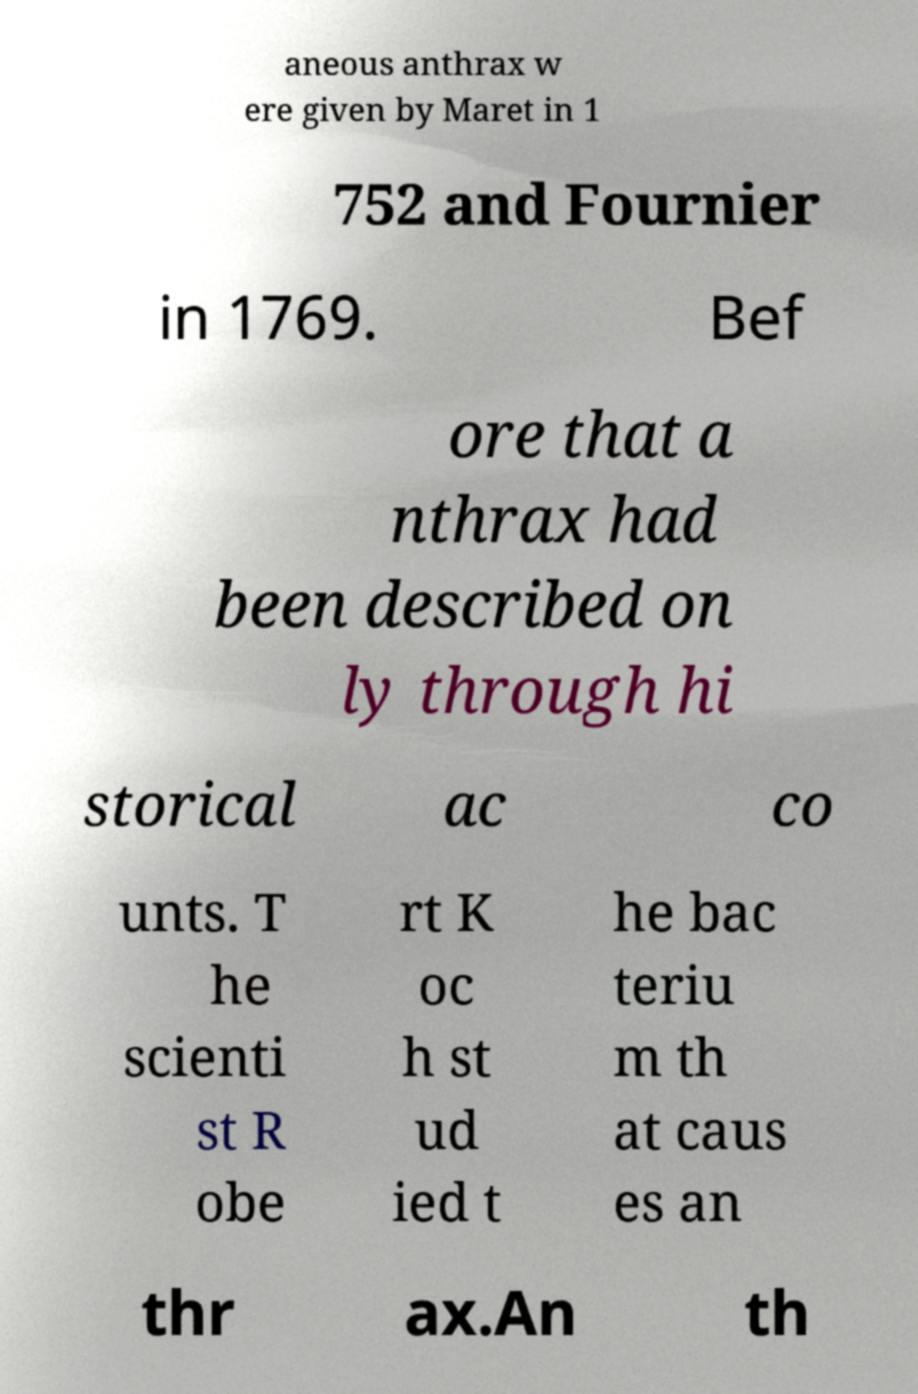Could you assist in decoding the text presented in this image and type it out clearly? aneous anthrax w ere given by Maret in 1 752 and Fournier in 1769. Bef ore that a nthrax had been described on ly through hi storical ac co unts. T he scienti st R obe rt K oc h st ud ied t he bac teriu m th at caus es an thr ax.An th 